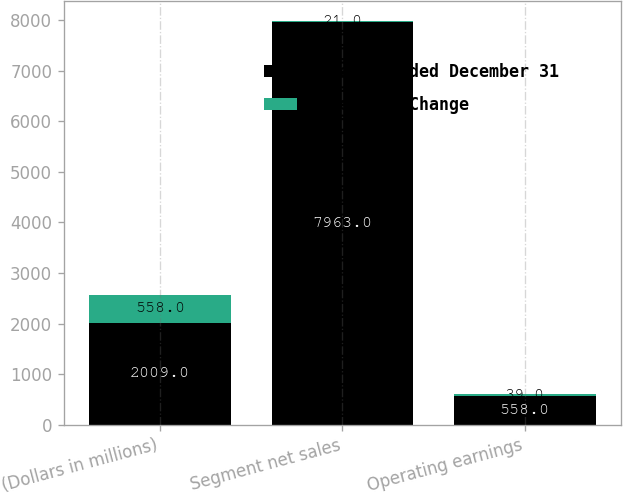Convert chart to OTSL. <chart><loc_0><loc_0><loc_500><loc_500><stacked_bar_chart><ecel><fcel>(Dollars in millions)<fcel>Segment net sales<fcel>Operating earnings<nl><fcel>Years Ended December 31<fcel>2009<fcel>7963<fcel>558<nl><fcel>Percent Change<fcel>558<fcel>21<fcel>39<nl></chart> 